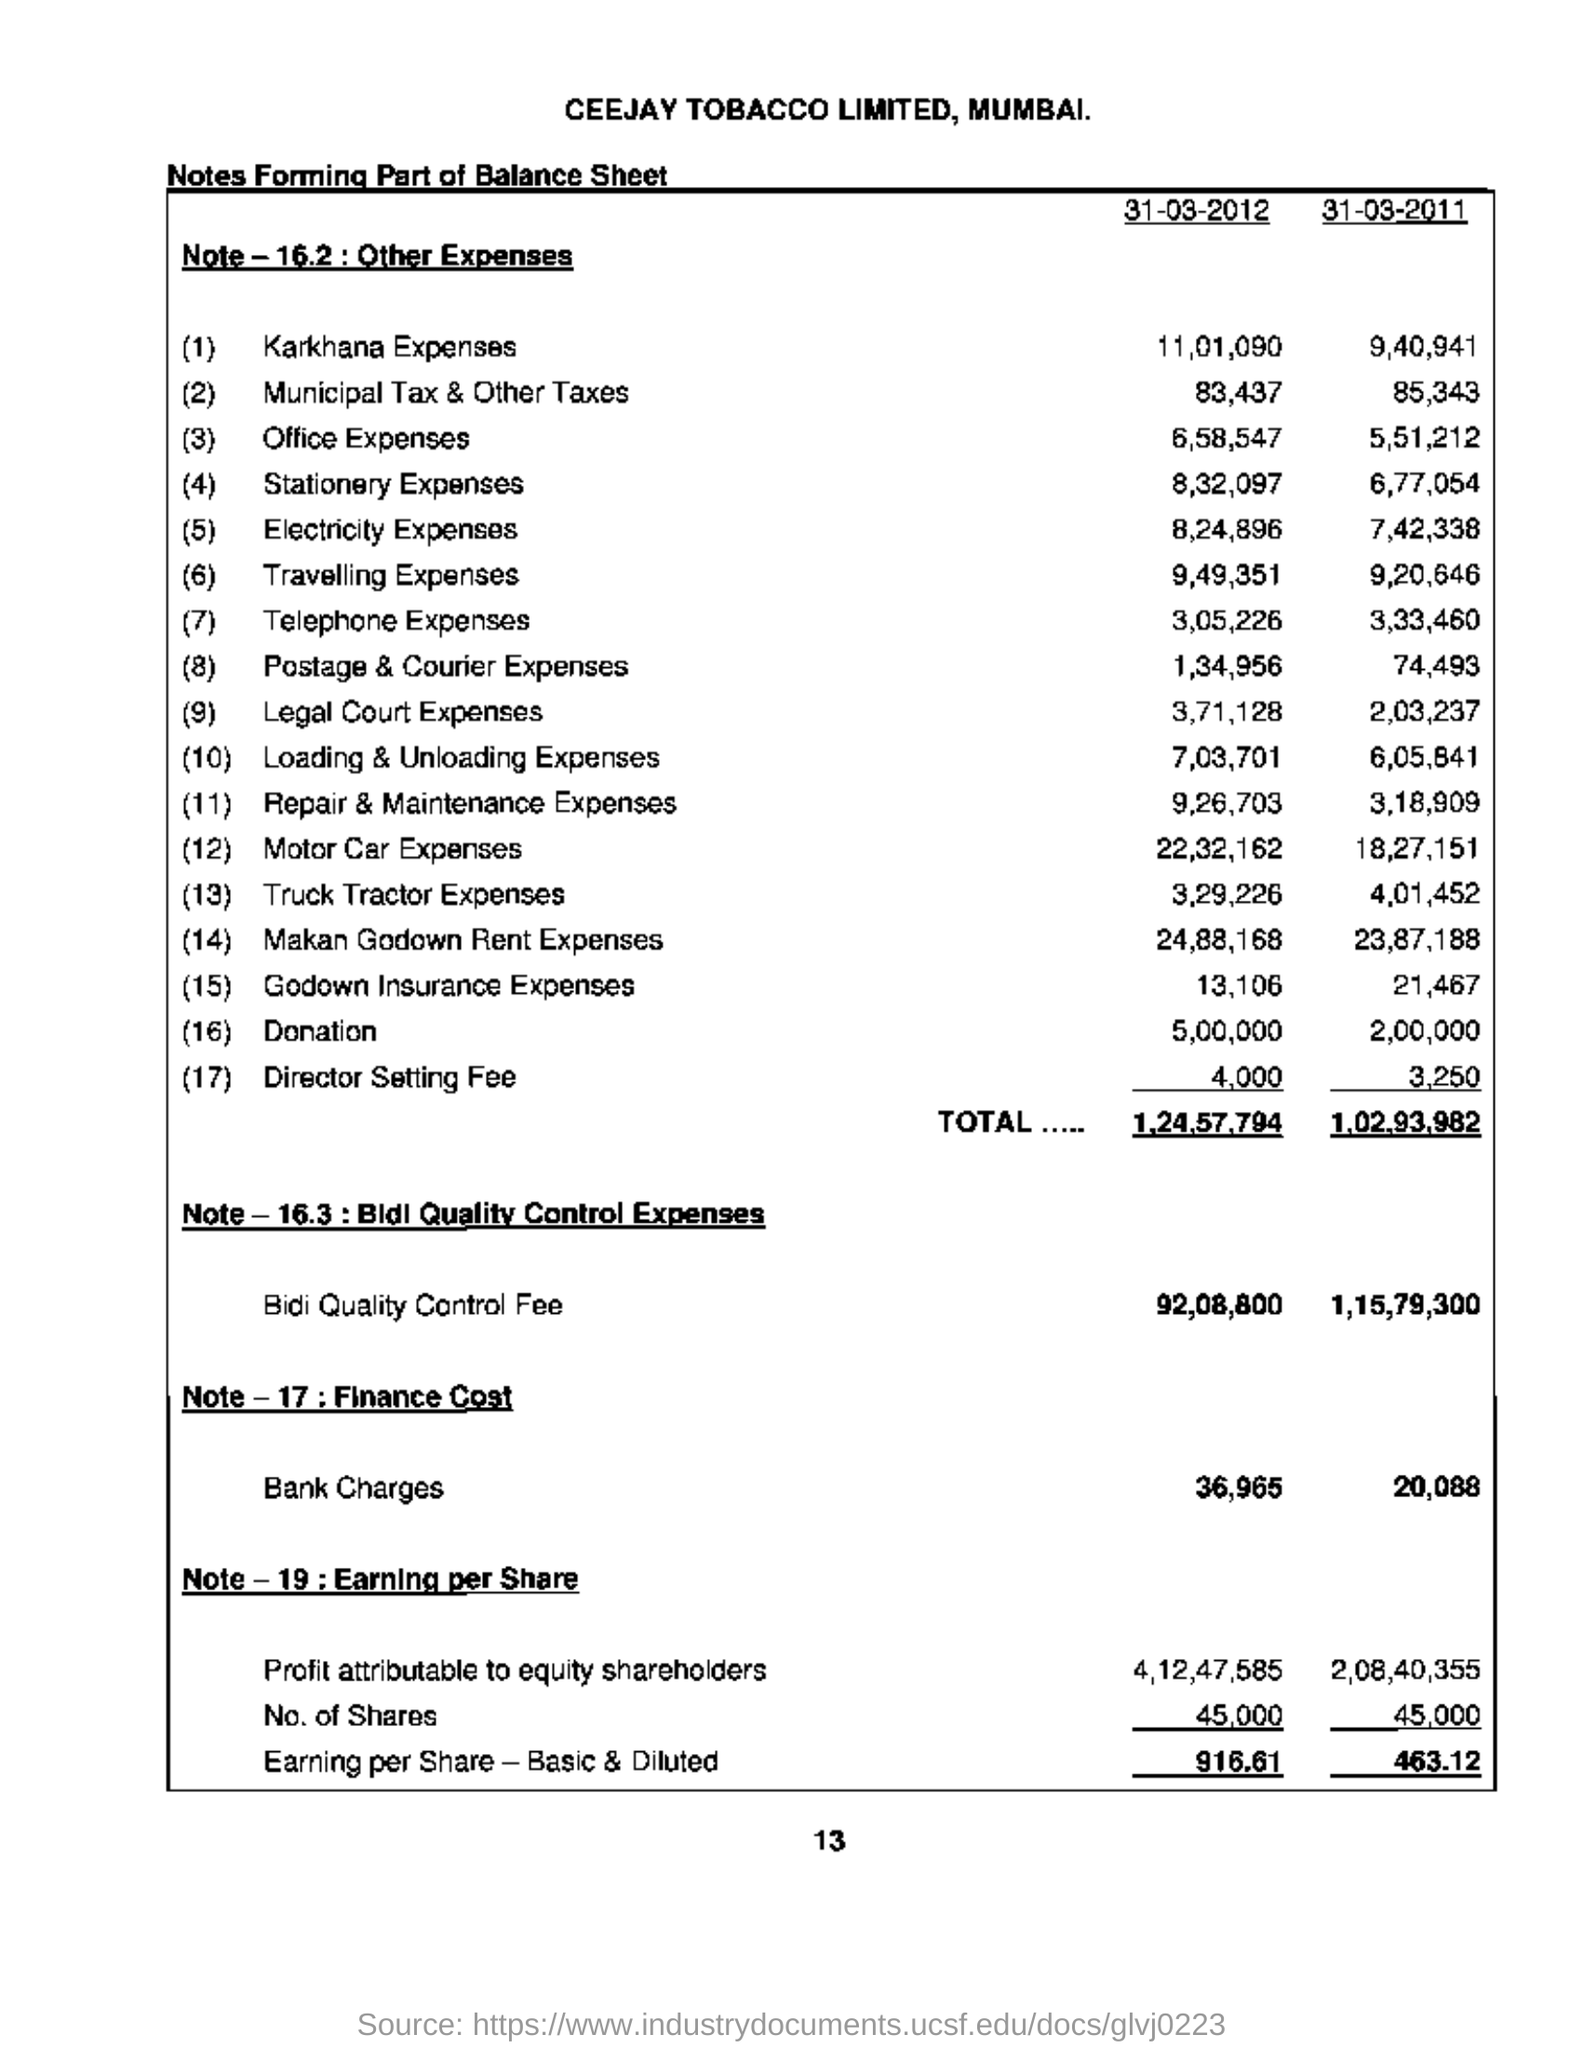What is the Karkhana Expenses for 31-03-2012?
Provide a short and direct response. 11,01,090. What is the Karkhana Expenses for 31-03-2011?
Provide a short and direct response. 9,40,941. What is the Donation for 31-03-2012?
Keep it short and to the point. 5,00,000. What is the Donation for 31-03-2011?
Provide a short and direct response. 2,00,000. What are the Bank Charges for 31-03-2012?
Make the answer very short. 36,965. What is the Office Expenses for 31-03-2012?
Offer a very short reply. 6,58,547. 